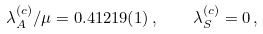<formula> <loc_0><loc_0><loc_500><loc_500>\lambda _ { A } ^ { ( c ) } / \mu = 0 . 4 1 2 1 9 ( 1 ) \, , \quad \lambda _ { S } ^ { ( c ) } = 0 \, ,</formula> 